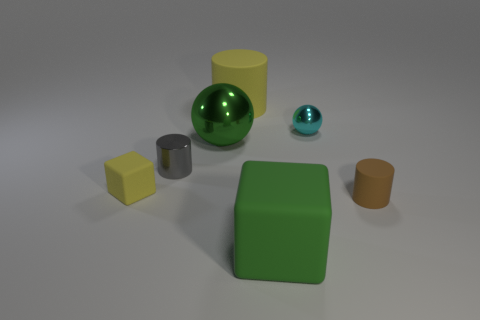Add 3 big gray things. How many objects exist? 10 Subtract all cubes. How many objects are left? 5 Subtract 1 green cubes. How many objects are left? 6 Subtract all small purple metal objects. Subtract all brown things. How many objects are left? 6 Add 4 rubber things. How many rubber things are left? 8 Add 4 big green matte objects. How many big green matte objects exist? 5 